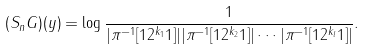Convert formula to latex. <formula><loc_0><loc_0><loc_500><loc_500>( S _ { n } G ) ( y ) = \log \frac { 1 } { | \pi ^ { - 1 } [ 1 2 ^ { k _ { 1 } } 1 ] | | \pi ^ { - 1 } [ 1 2 ^ { k _ { 2 } } 1 ] | \cdots | \pi ^ { - 1 } [ 1 2 ^ { k _ { l } } 1 ] | } .</formula> 